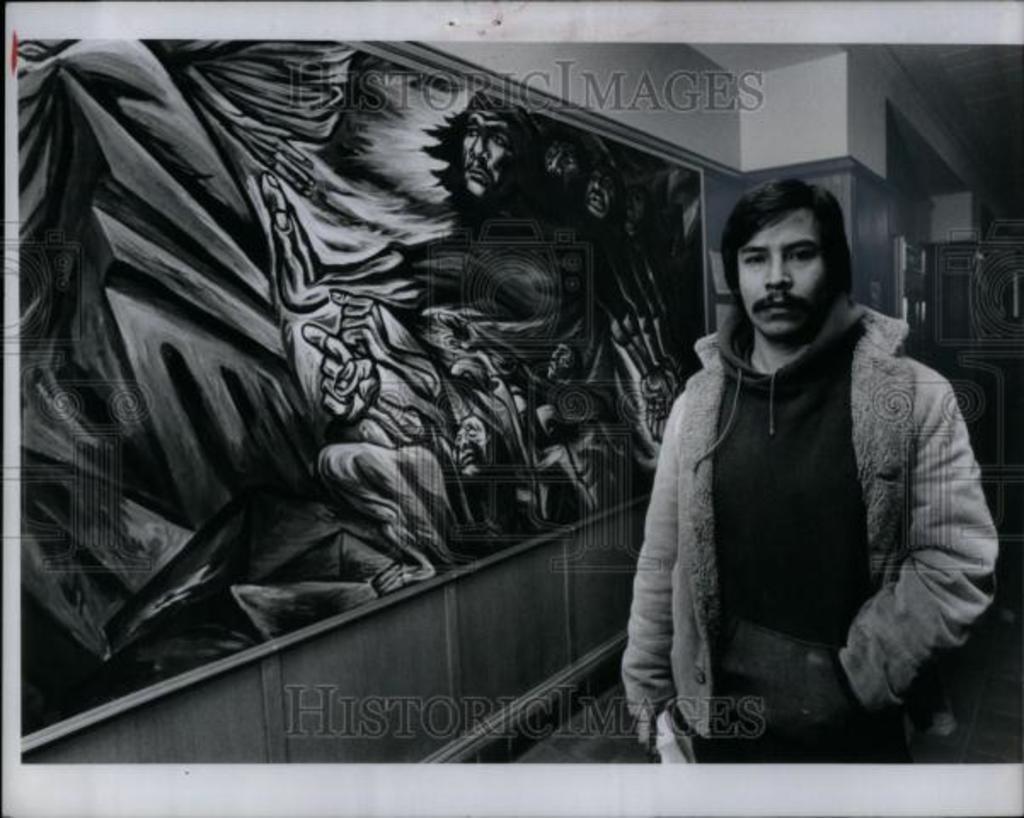How would you summarize this image in a sentence or two? On the right side of the image, we can see a person is standing, watching and holding some object. Background there is a painting and wall. Here we can see watermarks in the image. 